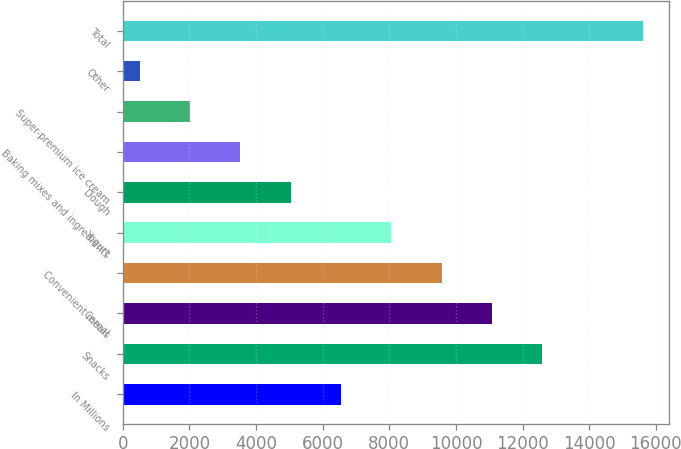<chart> <loc_0><loc_0><loc_500><loc_500><bar_chart><fcel>In Millions<fcel>Snacks<fcel>Cereal<fcel>Convenient meals<fcel>Yogurt<fcel>Dough<fcel>Baking mixes and ingredients<fcel>Super-premium ice cream<fcel>Other<fcel>Total<nl><fcel>6550.44<fcel>12596.7<fcel>11085.1<fcel>9573.56<fcel>8062<fcel>5038.88<fcel>3527.32<fcel>2015.76<fcel>504.2<fcel>15619.8<nl></chart> 